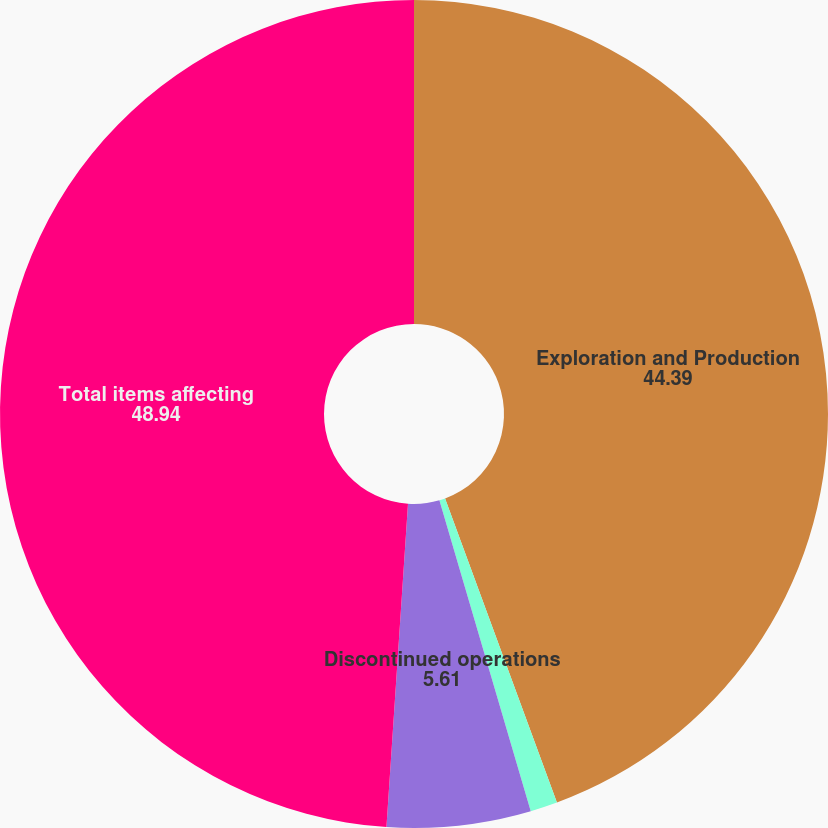Convert chart to OTSL. <chart><loc_0><loc_0><loc_500><loc_500><pie_chart><fcel>Exploration and Production<fcel>Corporate Interest and Other<fcel>Discontinued operations<fcel>Total items affecting<nl><fcel>44.39%<fcel>1.06%<fcel>5.61%<fcel>48.94%<nl></chart> 